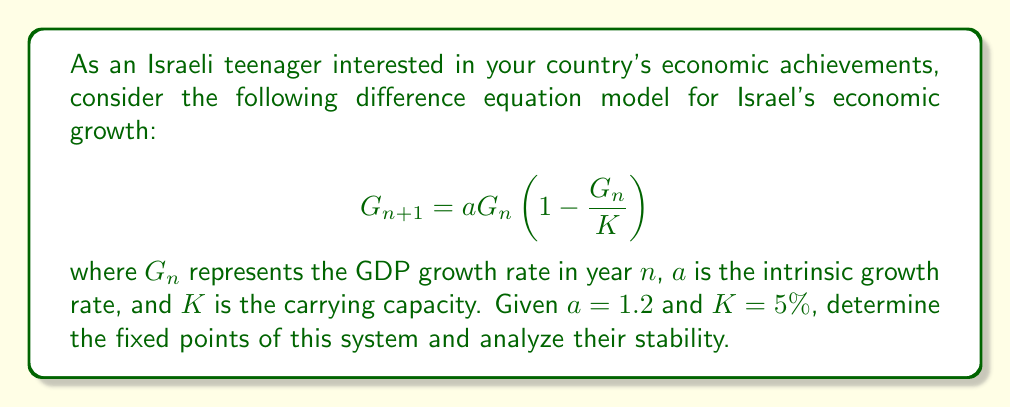What is the answer to this math problem? Let's approach this step-by-step:

1) To find the fixed points, we set $G_{n+1} = G_n = G^*$:

   $$G^* = aG^*(1 - \frac{G^*}{K})$$

2) Solving this equation:
   
   $$G^* = 0$$ or $$aG^*(1 - \frac{G^*}{K}) = G^*$$
   
   $$1 = a(1 - \frac{G^*}{K})$$
   
   $$\frac{G^*}{K} = 1 - \frac{1}{a}$$
   
   $$G^* = K(1 - \frac{1}{a}) = 5\%(1 - \frac{1}{1.2}) = 0.833\%$$

3) So, we have two fixed points: $G^*_1 = 0$ and $G^*_2 = 0.833\%$

4) To analyze stability, we calculate the derivative of the function at each fixed point:

   $$f'(G) = a(1 - \frac{2G}{K})$$

5) For $G^*_1 = 0$:
   
   $$f'(0) = a = 1.2$$
   
   Since $|f'(0)| > 1$, this fixed point is unstable.

6) For $G^*_2 = 0.833\%$:
   
   $$f'(0.833\%) = 1.2(1 - \frac{2(0.833\%)}{5\%}) = 0.8$$
   
   Since $|f'(0.833\%)| < 1$, this fixed point is stable.
Answer: Two fixed points: $G^*_1 = 0$ (unstable) and $G^*_2 = 0.833\%$ (stable). 